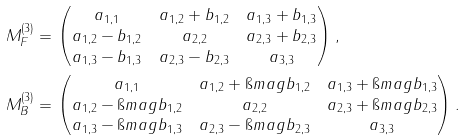<formula> <loc_0><loc_0><loc_500><loc_500>M ^ { ( 3 ) } _ { F } & = \begin{pmatrix} a _ { 1 , 1 } & a _ { 1 , 2 } + b _ { 1 , 2 } & a _ { 1 , 3 } + b _ { 1 , 3 } \\ a _ { 1 , 2 } - b _ { 1 , 2 } & a _ { 2 , 2 } & a _ { 2 , 3 } + b _ { 2 , 3 } \\ a _ { 1 , 3 } - b _ { 1 , 3 } & a _ { 2 , 3 } - b _ { 2 , 3 } & a _ { 3 , 3 } \end{pmatrix} , \\ M ^ { ( 3 ) } _ { B } & = \begin{pmatrix} a _ { 1 , 1 } & a _ { 1 , 2 } + \i m a g b _ { 1 , 2 } & a _ { 1 , 3 } + \i m a g b _ { 1 , 3 } \\ a _ { 1 , 2 } - \i m a g b _ { 1 , 2 } & a _ { 2 , 2 } & a _ { 2 , 3 } + \i m a g b _ { 2 , 3 } \\ a _ { 1 , 3 } - \i m a g b _ { 1 , 3 } & a _ { 2 , 3 } - \i m a g b _ { 2 , 3 } & a _ { 3 , 3 } \end{pmatrix} .</formula> 